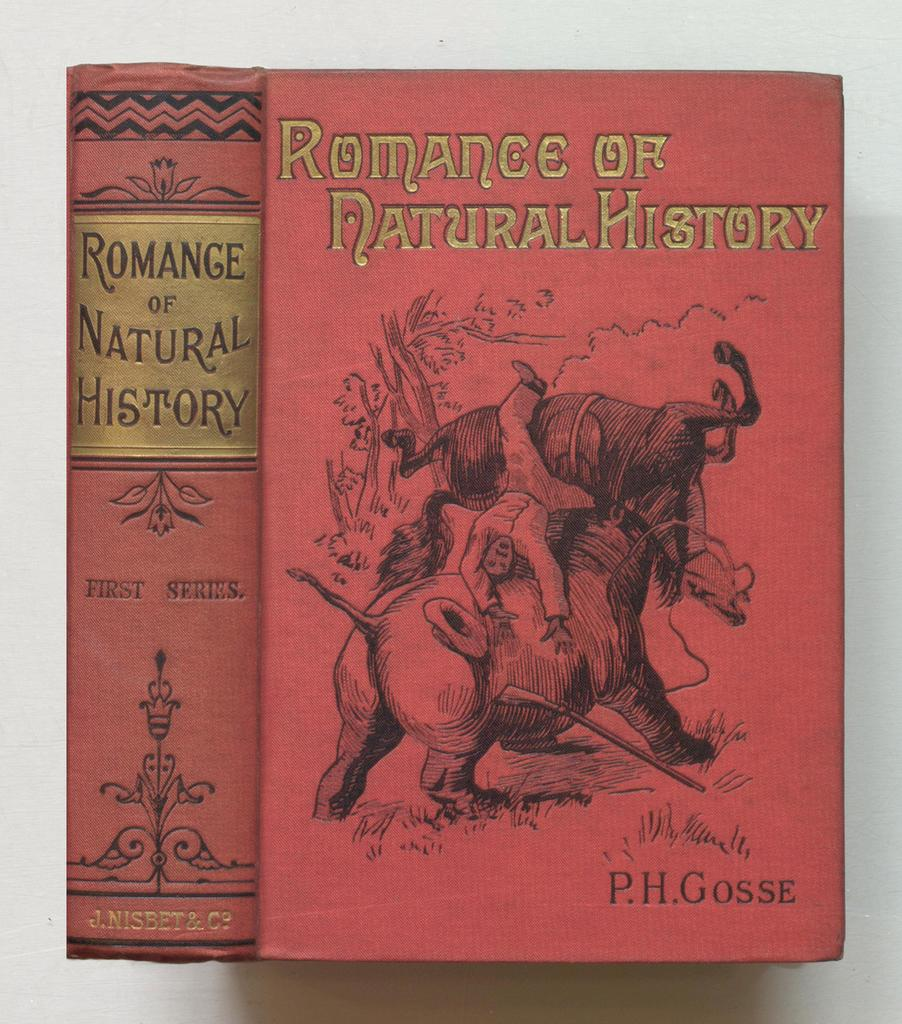What is present in the image? There is a book in the image. What is depicted on the book cover? There is an elephant on the book cover. What type of building is shown in the image? There is no building present in the image; it only features a book with an elephant on the cover. Can you see any cobwebs in the image? There are no cobwebs present in the image. 